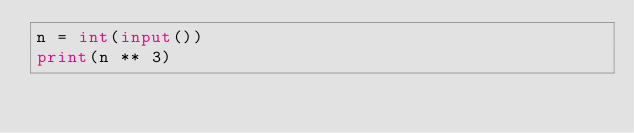Convert code to text. <code><loc_0><loc_0><loc_500><loc_500><_Python_>n = int(input())
print(n ** 3)
</code> 